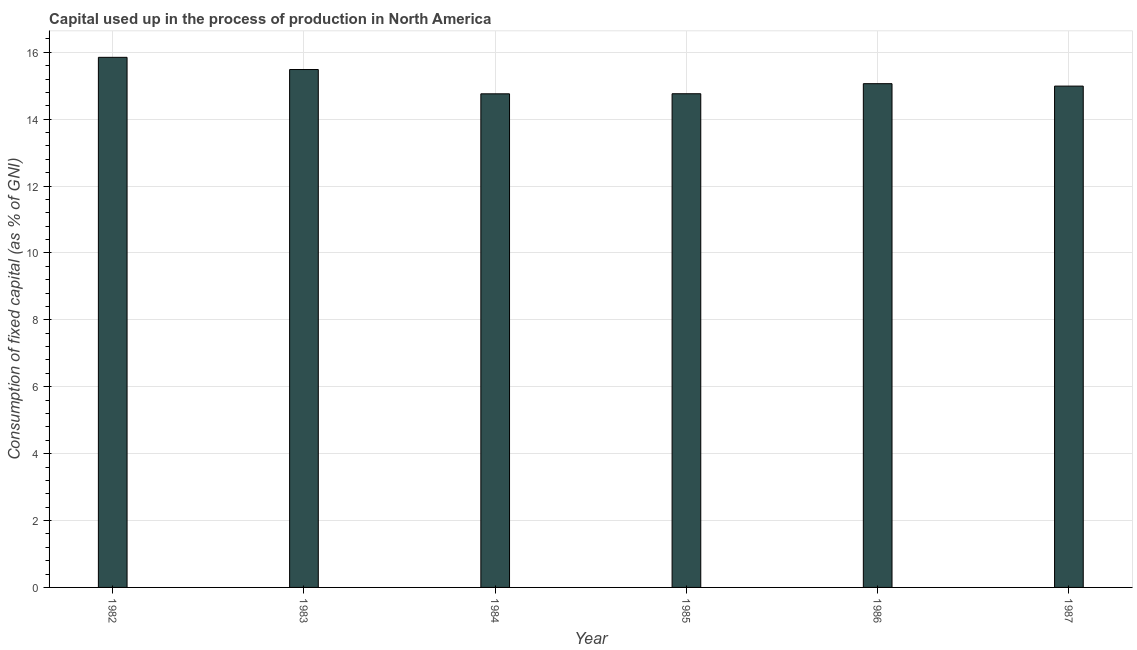Does the graph contain any zero values?
Your response must be concise. No. Does the graph contain grids?
Offer a very short reply. Yes. What is the title of the graph?
Your answer should be compact. Capital used up in the process of production in North America. What is the label or title of the X-axis?
Keep it short and to the point. Year. What is the label or title of the Y-axis?
Your answer should be compact. Consumption of fixed capital (as % of GNI). What is the consumption of fixed capital in 1982?
Ensure brevity in your answer.  15.85. Across all years, what is the maximum consumption of fixed capital?
Ensure brevity in your answer.  15.85. Across all years, what is the minimum consumption of fixed capital?
Your response must be concise. 14.76. What is the sum of the consumption of fixed capital?
Make the answer very short. 90.9. What is the difference between the consumption of fixed capital in 1982 and 1986?
Your response must be concise. 0.79. What is the average consumption of fixed capital per year?
Make the answer very short. 15.15. What is the median consumption of fixed capital?
Offer a very short reply. 15.02. In how many years, is the consumption of fixed capital greater than 7.6 %?
Your response must be concise. 6. Do a majority of the years between 1984 and 1982 (inclusive) have consumption of fixed capital greater than 2 %?
Your answer should be very brief. Yes. What is the ratio of the consumption of fixed capital in 1985 to that in 1986?
Your response must be concise. 0.98. Is the consumption of fixed capital in 1985 less than that in 1987?
Your answer should be very brief. Yes. Is the difference between the consumption of fixed capital in 1982 and 1983 greater than the difference between any two years?
Your answer should be compact. No. What is the difference between the highest and the second highest consumption of fixed capital?
Ensure brevity in your answer.  0.36. Is the sum of the consumption of fixed capital in 1984 and 1987 greater than the maximum consumption of fixed capital across all years?
Your answer should be very brief. Yes. What is the difference between the highest and the lowest consumption of fixed capital?
Make the answer very short. 1.09. How many bars are there?
Provide a short and direct response. 6. Are the values on the major ticks of Y-axis written in scientific E-notation?
Provide a succinct answer. No. What is the Consumption of fixed capital (as % of GNI) of 1982?
Ensure brevity in your answer.  15.85. What is the Consumption of fixed capital (as % of GNI) of 1983?
Your response must be concise. 15.48. What is the Consumption of fixed capital (as % of GNI) in 1984?
Offer a terse response. 14.76. What is the Consumption of fixed capital (as % of GNI) of 1985?
Keep it short and to the point. 14.76. What is the Consumption of fixed capital (as % of GNI) in 1986?
Your response must be concise. 15.06. What is the Consumption of fixed capital (as % of GNI) in 1987?
Ensure brevity in your answer.  14.99. What is the difference between the Consumption of fixed capital (as % of GNI) in 1982 and 1983?
Provide a succinct answer. 0.36. What is the difference between the Consumption of fixed capital (as % of GNI) in 1982 and 1984?
Give a very brief answer. 1.09. What is the difference between the Consumption of fixed capital (as % of GNI) in 1982 and 1985?
Provide a short and direct response. 1.09. What is the difference between the Consumption of fixed capital (as % of GNI) in 1982 and 1986?
Your response must be concise. 0.79. What is the difference between the Consumption of fixed capital (as % of GNI) in 1982 and 1987?
Keep it short and to the point. 0.86. What is the difference between the Consumption of fixed capital (as % of GNI) in 1983 and 1984?
Provide a short and direct response. 0.73. What is the difference between the Consumption of fixed capital (as % of GNI) in 1983 and 1985?
Make the answer very short. 0.72. What is the difference between the Consumption of fixed capital (as % of GNI) in 1983 and 1986?
Give a very brief answer. 0.42. What is the difference between the Consumption of fixed capital (as % of GNI) in 1983 and 1987?
Give a very brief answer. 0.5. What is the difference between the Consumption of fixed capital (as % of GNI) in 1984 and 1985?
Provide a short and direct response. -0. What is the difference between the Consumption of fixed capital (as % of GNI) in 1984 and 1986?
Offer a terse response. -0.3. What is the difference between the Consumption of fixed capital (as % of GNI) in 1984 and 1987?
Offer a terse response. -0.23. What is the difference between the Consumption of fixed capital (as % of GNI) in 1985 and 1986?
Offer a terse response. -0.3. What is the difference between the Consumption of fixed capital (as % of GNI) in 1985 and 1987?
Your answer should be very brief. -0.23. What is the difference between the Consumption of fixed capital (as % of GNI) in 1986 and 1987?
Give a very brief answer. 0.07. What is the ratio of the Consumption of fixed capital (as % of GNI) in 1982 to that in 1984?
Ensure brevity in your answer.  1.07. What is the ratio of the Consumption of fixed capital (as % of GNI) in 1982 to that in 1985?
Your response must be concise. 1.07. What is the ratio of the Consumption of fixed capital (as % of GNI) in 1982 to that in 1986?
Ensure brevity in your answer.  1.05. What is the ratio of the Consumption of fixed capital (as % of GNI) in 1982 to that in 1987?
Your response must be concise. 1.06. What is the ratio of the Consumption of fixed capital (as % of GNI) in 1983 to that in 1984?
Provide a short and direct response. 1.05. What is the ratio of the Consumption of fixed capital (as % of GNI) in 1983 to that in 1985?
Offer a very short reply. 1.05. What is the ratio of the Consumption of fixed capital (as % of GNI) in 1983 to that in 1986?
Keep it short and to the point. 1.03. What is the ratio of the Consumption of fixed capital (as % of GNI) in 1983 to that in 1987?
Provide a short and direct response. 1.03. What is the ratio of the Consumption of fixed capital (as % of GNI) in 1984 to that in 1986?
Provide a succinct answer. 0.98. What is the ratio of the Consumption of fixed capital (as % of GNI) in 1984 to that in 1987?
Provide a succinct answer. 0.98. What is the ratio of the Consumption of fixed capital (as % of GNI) in 1985 to that in 1987?
Offer a terse response. 0.98. 